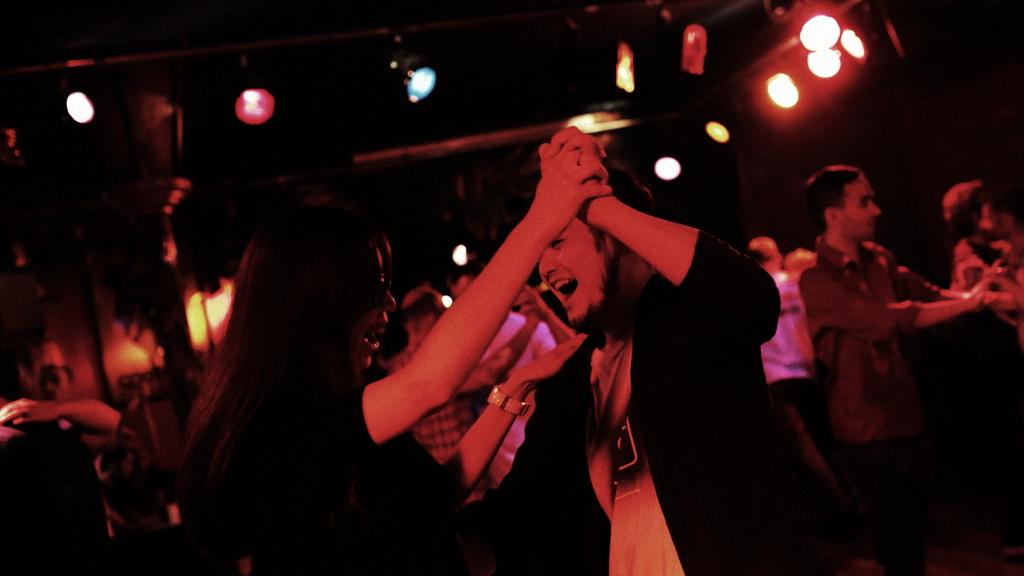What are the people in the image doing? The people in the image are dancing. What can be seen at the top of the image? There are lights at the top of the image. How would you describe the background of the image? The background of the image is dark. How many doors are visible in the image? There are no doors visible in the image; it features people dancing with lights in the background. What type of army is present in the image? There is no army present in the image; it features people dancing with lights in the background. 